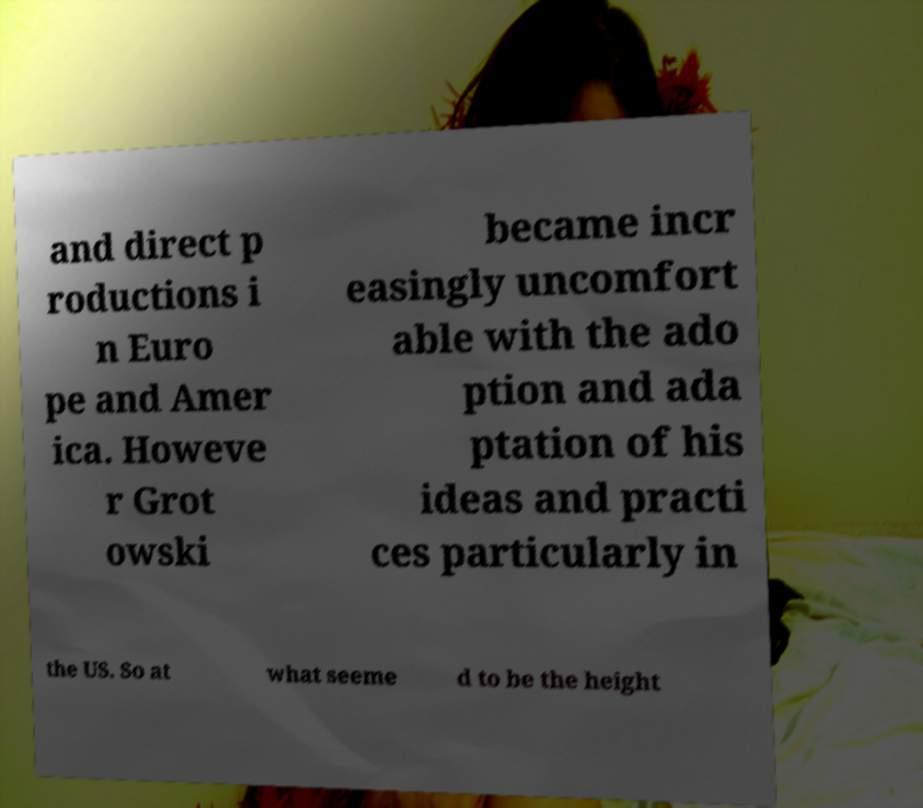Can you read and provide the text displayed in the image?This photo seems to have some interesting text. Can you extract and type it out for me? and direct p roductions i n Euro pe and Amer ica. Howeve r Grot owski became incr easingly uncomfort able with the ado ption and ada ptation of his ideas and practi ces particularly in the US. So at what seeme d to be the height 